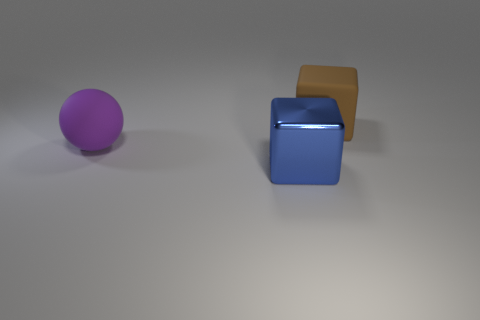How many small green cylinders are there?
Provide a succinct answer. 0. Does the big cube that is in front of the large brown matte object have the same material as the brown cube?
Keep it short and to the point. No. Are there any cyan rubber spheres of the same size as the shiny cube?
Keep it short and to the point. No. Do the big shiny object and the object that is behind the purple rubber sphere have the same shape?
Your answer should be compact. Yes. There is a matte object that is in front of the big matte object that is on the right side of the blue metal block; are there any big purple spheres that are to the left of it?
Offer a terse response. No. What size is the brown object?
Make the answer very short. Large. There is a big matte thing that is in front of the large brown rubber thing; is it the same shape as the blue object?
Offer a very short reply. No. There is another thing that is the same shape as the metal thing; what is its color?
Your response must be concise. Brown. Are there any other things that have the same material as the big blue object?
Offer a terse response. No. The big thing that is behind the metallic thing and in front of the big brown matte block is made of what material?
Keep it short and to the point. Rubber. 